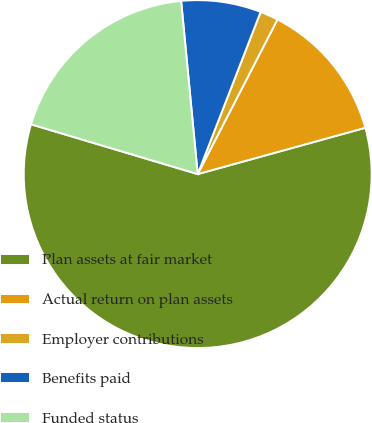Convert chart. <chart><loc_0><loc_0><loc_500><loc_500><pie_chart><fcel>Plan assets at fair market<fcel>Actual return on plan assets<fcel>Employer contributions<fcel>Benefits paid<fcel>Funded status<nl><fcel>58.91%<fcel>13.13%<fcel>1.69%<fcel>7.41%<fcel>18.86%<nl></chart> 